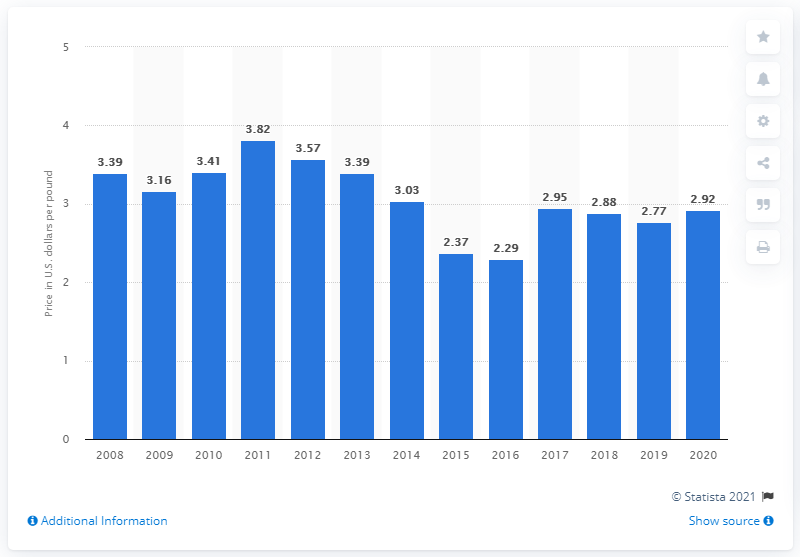Mention a couple of crucial points in this snapshot. In 2020, the average price per pound of copper produced by Barrick Gold was 2.92 dollars. 